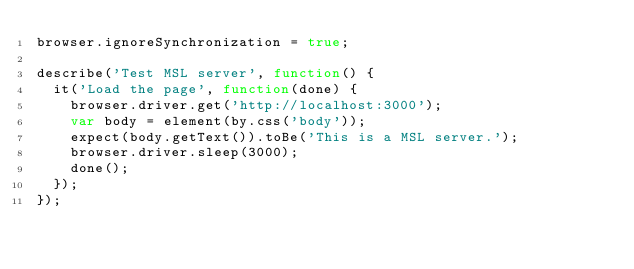<code> <loc_0><loc_0><loc_500><loc_500><_JavaScript_>browser.ignoreSynchronization = true;

describe('Test MSL server', function() {
	it('Load the page', function(done) {
		browser.driver.get('http://localhost:3000');
		var body = element(by.css('body'));
		expect(body.getText()).toBe('This is a MSL server.');
		browser.driver.sleep(3000);
		done();
	});
});
</code> 